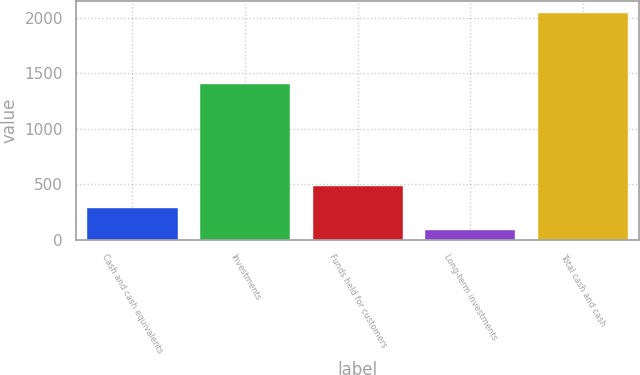Convert chart. <chart><loc_0><loc_0><loc_500><loc_500><bar_chart><fcel>Cash and cash equivalents<fcel>Investments<fcel>Funds held for customers<fcel>Long-term investments<fcel>Total cash and cash<nl><fcel>286.7<fcel>1407<fcel>482.4<fcel>91<fcel>2048<nl></chart> 